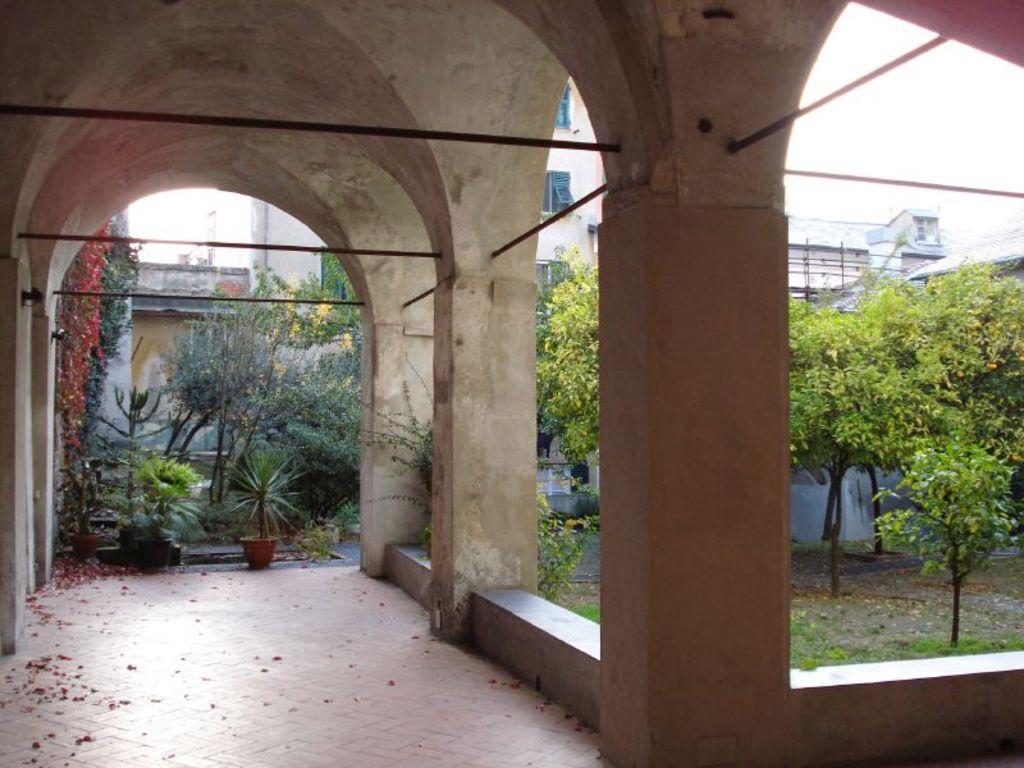Describe this image in one or two sentences. In this picture I see the path in front and I see pillars and I see few rows on the pillars. In the middle of this picture I see the plants and the trees. In the background I see the buildings. 